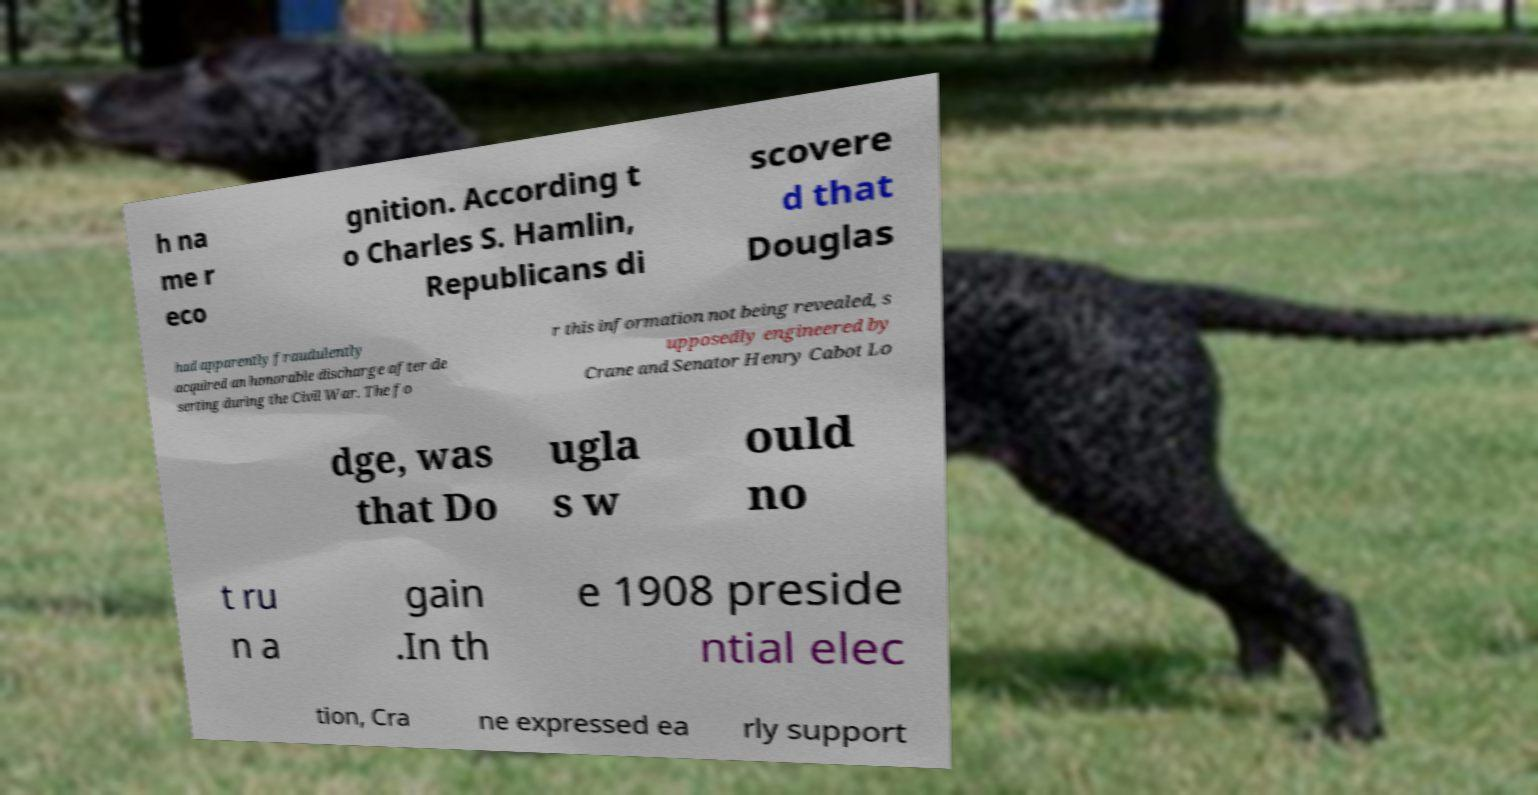Please read and relay the text visible in this image. What does it say? h na me r eco gnition. According t o Charles S. Hamlin, Republicans di scovere d that Douglas had apparently fraudulently acquired an honorable discharge after de serting during the Civil War. The fo r this information not being revealed, s upposedly engineered by Crane and Senator Henry Cabot Lo dge, was that Do ugla s w ould no t ru n a gain .In th e 1908 preside ntial elec tion, Cra ne expressed ea rly support 